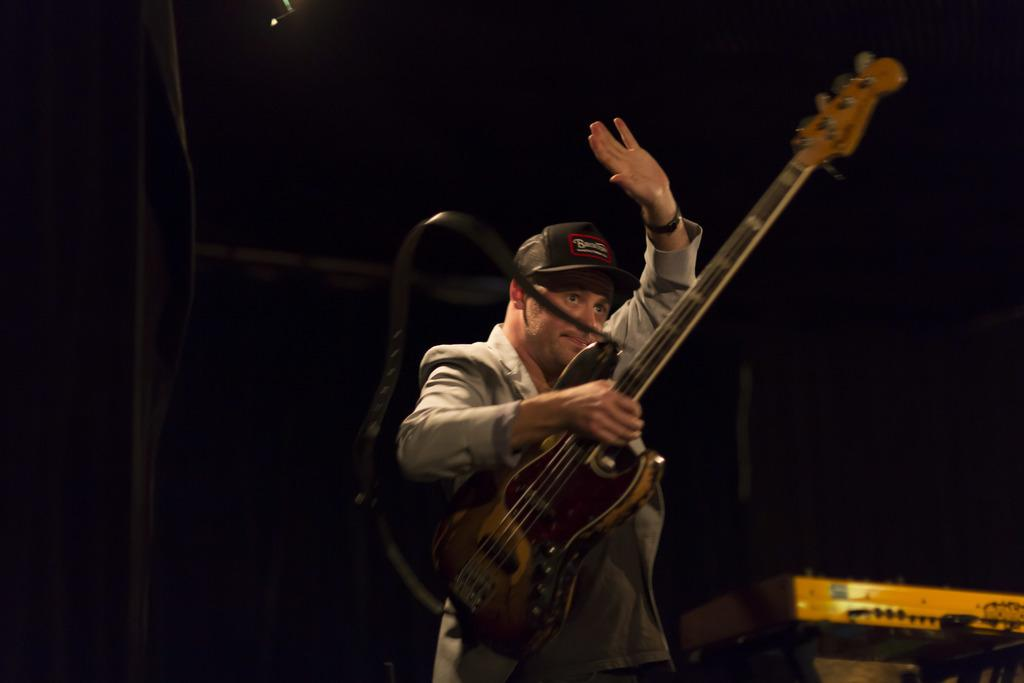What is the main subject of the image? The main subject of the image is a man. What is the man holding in his hand? The man is holding a guitar in his hand. What month is it in the image? The month is not mentioned or depicted in the image, so it cannot be determined. 